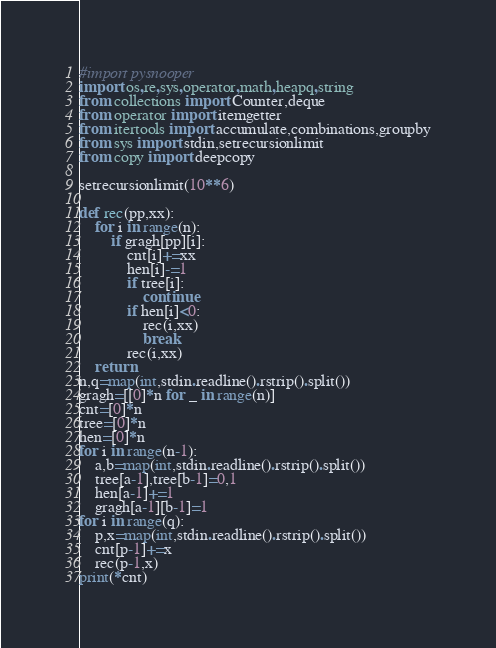<code> <loc_0><loc_0><loc_500><loc_500><_Python_>#import pysnooper
import os,re,sys,operator,math,heapq,string
from collections import Counter,deque
from operator import itemgetter
from itertools import accumulate,combinations,groupby
from sys import stdin,setrecursionlimit
from copy import deepcopy

setrecursionlimit(10**6)

def rec(pp,xx):
    for i in range(n):
        if gragh[pp][i]:
            cnt[i]+=xx
            hen[i]-=1
            if tree[i]:
                continue
            if hen[i]<0:
                rec(i,xx)
                break
            rec(i,xx)
    return
n,q=map(int,stdin.readline().rstrip().split())
gragh=[[0]*n for _ in range(n)]
cnt=[0]*n
tree=[0]*n
hen=[0]*n
for i in range(n-1):
    a,b=map(int,stdin.readline().rstrip().split())
    tree[a-1],tree[b-1]=0,1
    hen[a-1]+=1
    gragh[a-1][b-1]=1
for i in range(q):
    p,x=map(int,stdin.readline().rstrip().split())
    cnt[p-1]+=x
    rec(p-1,x)
print(*cnt)</code> 